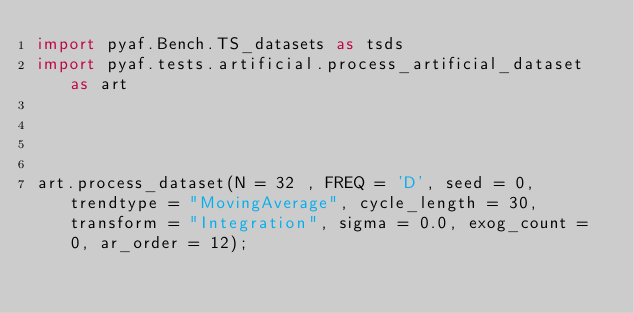<code> <loc_0><loc_0><loc_500><loc_500><_Python_>import pyaf.Bench.TS_datasets as tsds
import pyaf.tests.artificial.process_artificial_dataset as art




art.process_dataset(N = 32 , FREQ = 'D', seed = 0, trendtype = "MovingAverage", cycle_length = 30, transform = "Integration", sigma = 0.0, exog_count = 0, ar_order = 12);</code> 